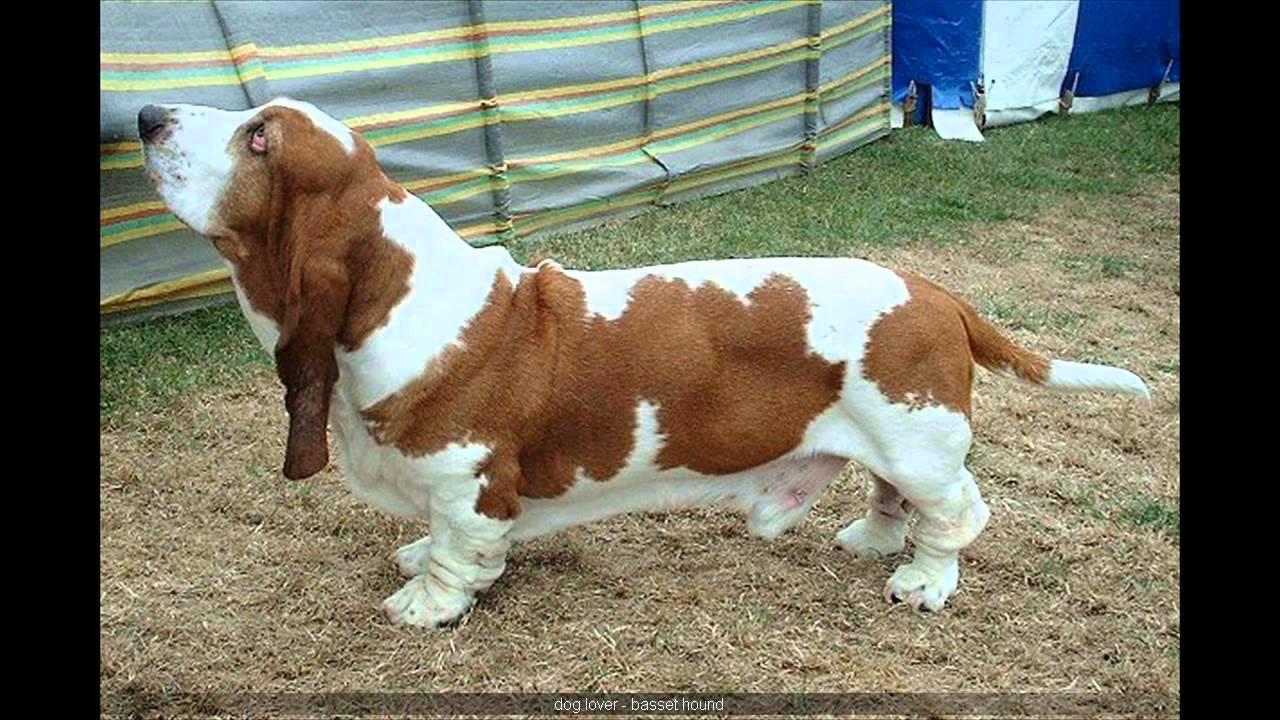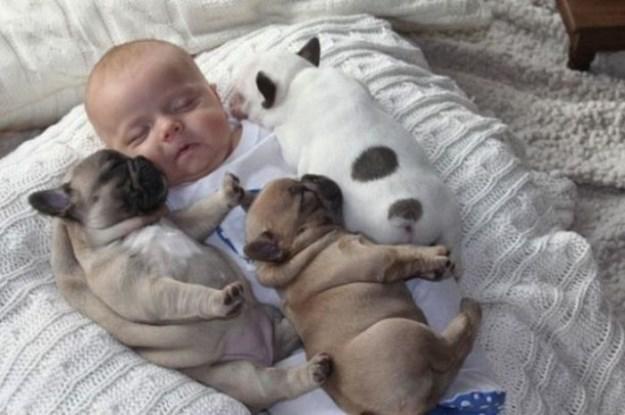The first image is the image on the left, the second image is the image on the right. Examine the images to the left and right. Is the description "In the right image, there's a single basset hound running through the grass." accurate? Answer yes or no. No. The first image is the image on the left, the second image is the image on the right. For the images displayed, is the sentence "There is at least one pug and one baby." factually correct? Answer yes or no. Yes. 